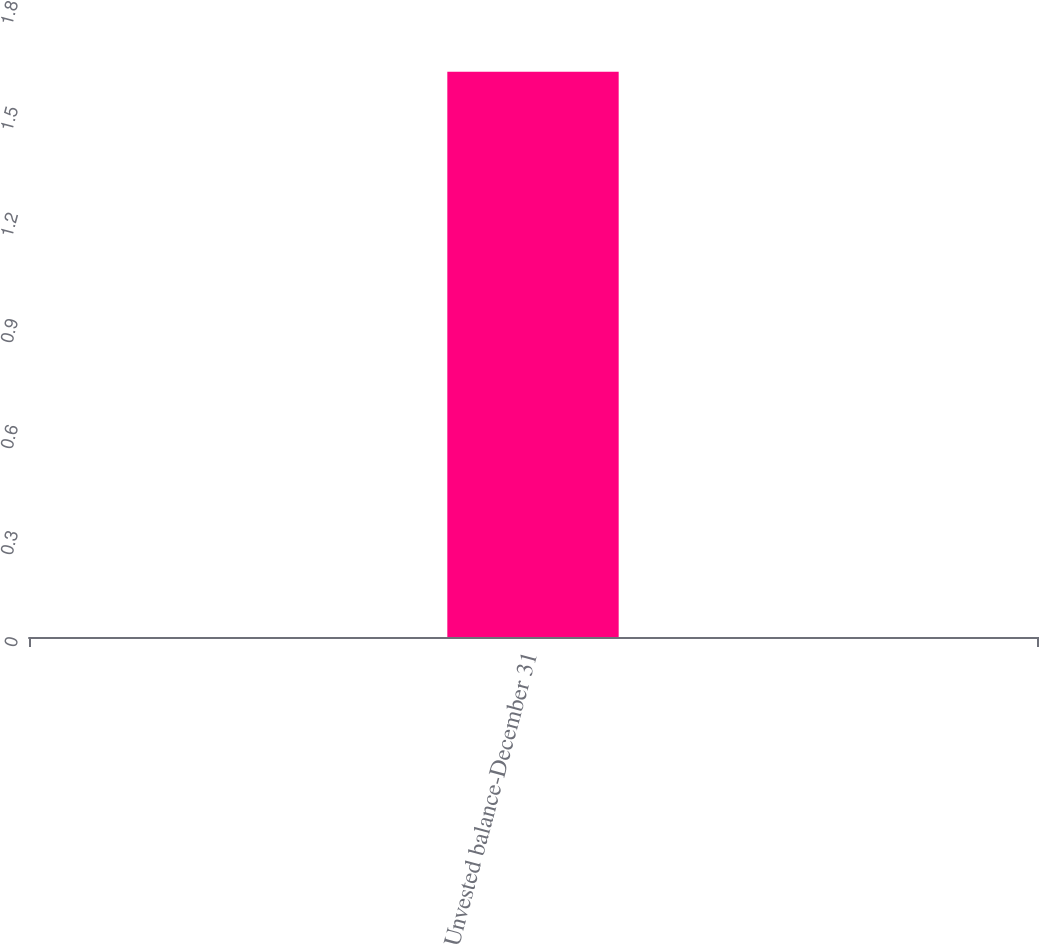Convert chart. <chart><loc_0><loc_0><loc_500><loc_500><bar_chart><fcel>Unvested balance-December 31<nl><fcel>1.6<nl></chart> 